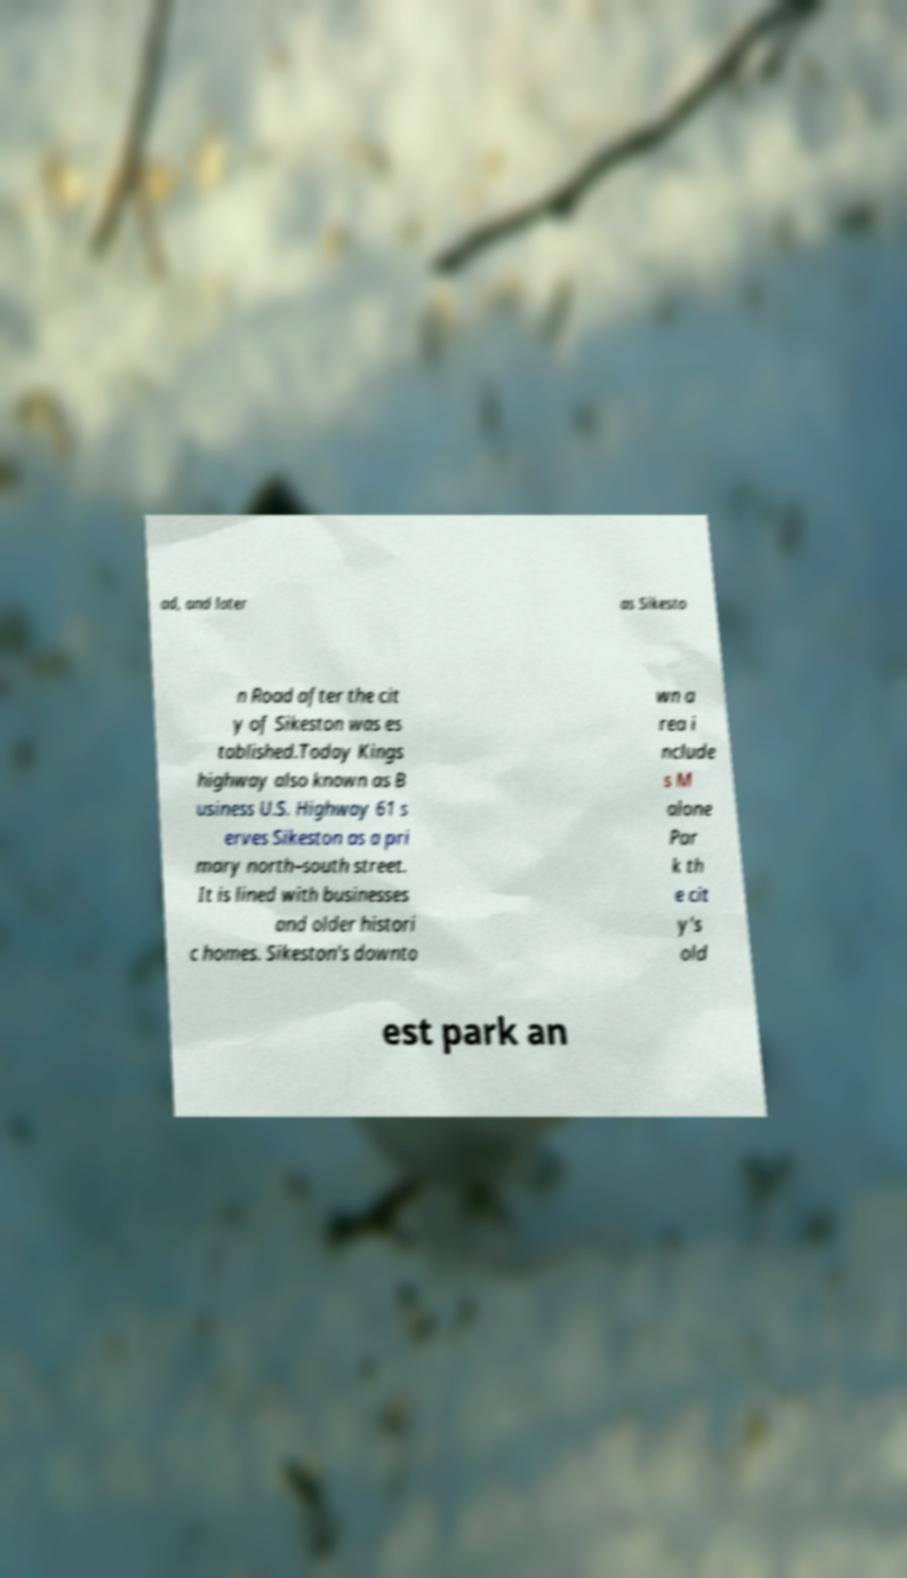For documentation purposes, I need the text within this image transcribed. Could you provide that? ad, and later as Sikesto n Road after the cit y of Sikeston was es tablished.Today Kings highway also known as B usiness U.S. Highway 61 s erves Sikeston as a pri mary north–south street. It is lined with businesses and older histori c homes. Sikeston's downto wn a rea i nclude s M alone Par k th e cit y's old est park an 